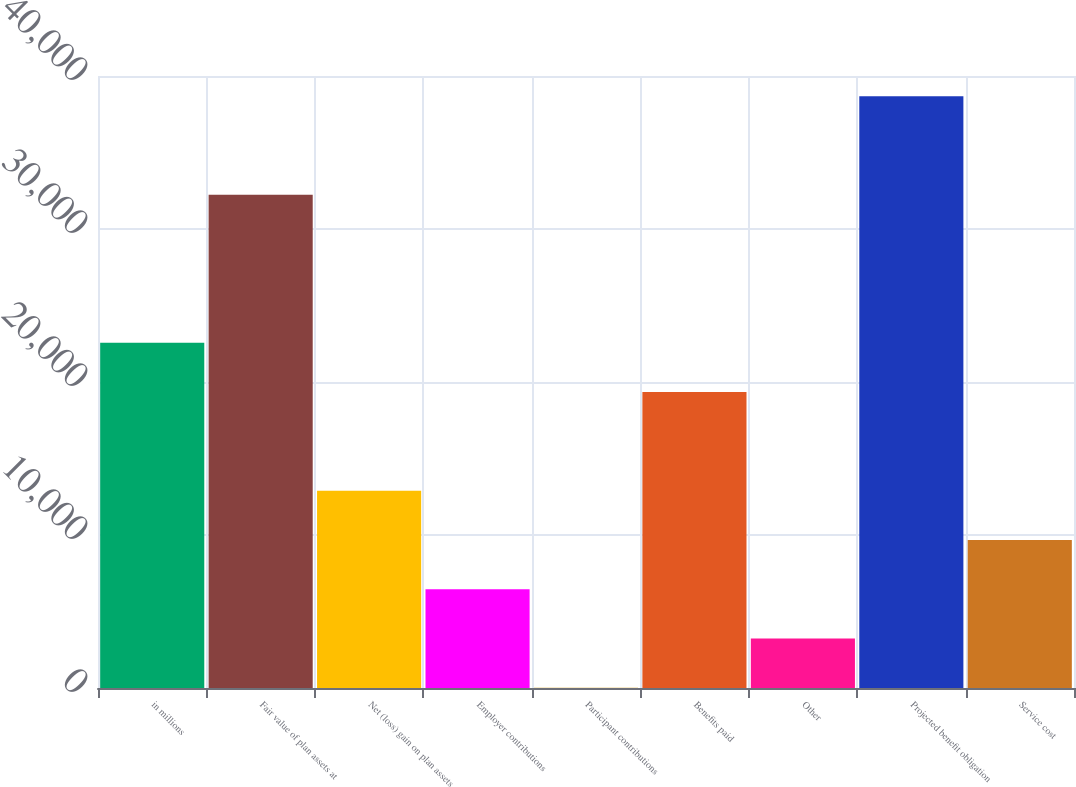Convert chart to OTSL. <chart><loc_0><loc_0><loc_500><loc_500><bar_chart><fcel>in millions<fcel>Fair value of plan assets at<fcel>Net (loss) gain on plan assets<fcel>Employer contributions<fcel>Participant contributions<fcel>Benefits paid<fcel>Other<fcel>Projected benefit obligation<fcel>Service cost<nl><fcel>22564.4<fcel>32231<fcel>12897.8<fcel>6453.4<fcel>9<fcel>19342.2<fcel>3231.2<fcel>38675.4<fcel>9675.6<nl></chart> 